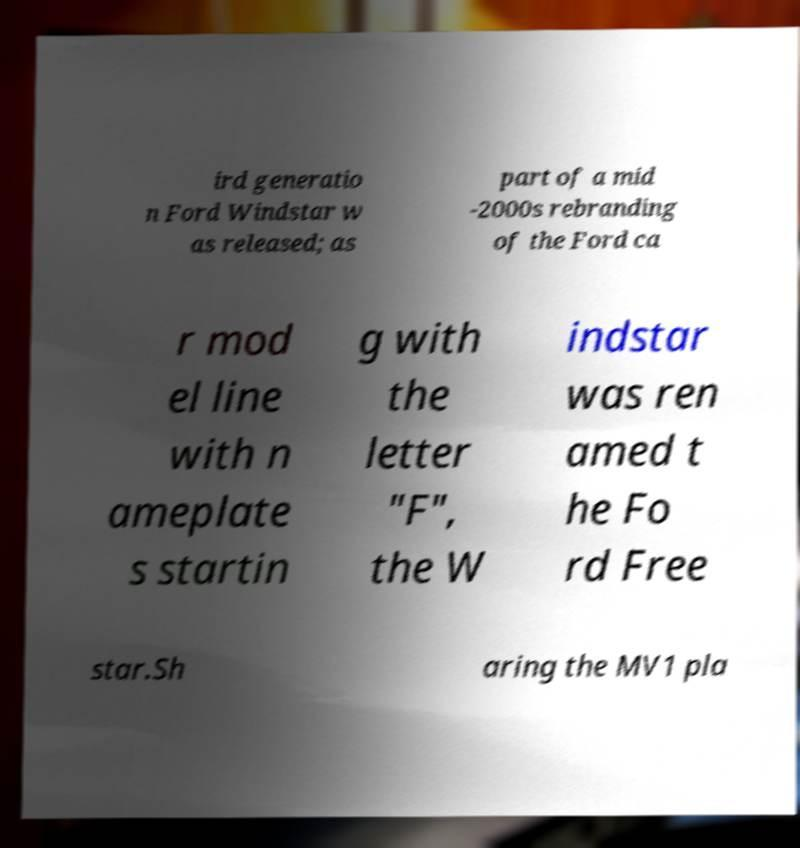I need the written content from this picture converted into text. Can you do that? ird generatio n Ford Windstar w as released; as part of a mid -2000s rebranding of the Ford ca r mod el line with n ameplate s startin g with the letter "F", the W indstar was ren amed t he Fo rd Free star.Sh aring the MV1 pla 